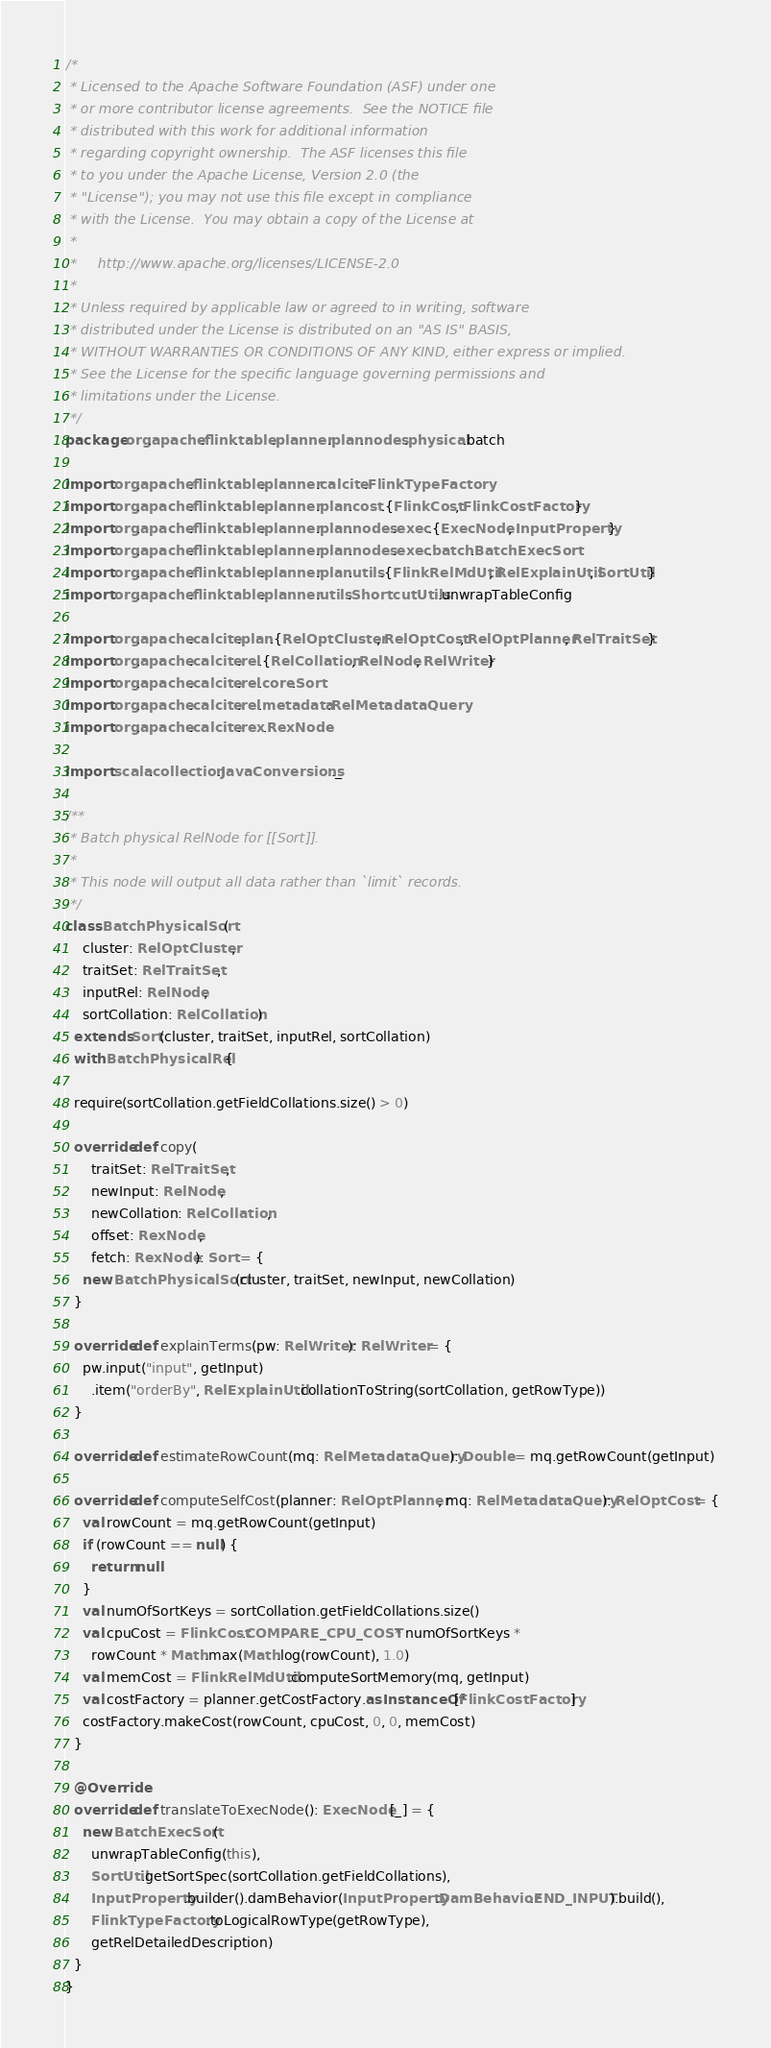<code> <loc_0><loc_0><loc_500><loc_500><_Scala_>/*
 * Licensed to the Apache Software Foundation (ASF) under one
 * or more contributor license agreements.  See the NOTICE file
 * distributed with this work for additional information
 * regarding copyright ownership.  The ASF licenses this file
 * to you under the Apache License, Version 2.0 (the
 * "License"); you may not use this file except in compliance
 * with the License.  You may obtain a copy of the License at
 *
 *     http://www.apache.org/licenses/LICENSE-2.0
 *
 * Unless required by applicable law or agreed to in writing, software
 * distributed under the License is distributed on an "AS IS" BASIS,
 * WITHOUT WARRANTIES OR CONDITIONS OF ANY KIND, either express or implied.
 * See the License for the specific language governing permissions and
 * limitations under the License.
 */
package org.apache.flink.table.planner.plan.nodes.physical.batch

import org.apache.flink.table.planner.calcite.FlinkTypeFactory
import org.apache.flink.table.planner.plan.cost.{FlinkCost, FlinkCostFactory}
import org.apache.flink.table.planner.plan.nodes.exec.{ExecNode, InputProperty}
import org.apache.flink.table.planner.plan.nodes.exec.batch.BatchExecSort
import org.apache.flink.table.planner.plan.utils.{FlinkRelMdUtil, RelExplainUtil, SortUtil}
import org.apache.flink.table.planner.utils.ShortcutUtils.unwrapTableConfig

import org.apache.calcite.plan.{RelOptCluster, RelOptCost, RelOptPlanner, RelTraitSet}
import org.apache.calcite.rel.{RelCollation, RelNode, RelWriter}
import org.apache.calcite.rel.core.Sort
import org.apache.calcite.rel.metadata.RelMetadataQuery
import org.apache.calcite.rex.RexNode

import scala.collection.JavaConversions._

/**
 * Batch physical RelNode for [[Sort]].
 *
 * This node will output all data rather than `limit` records.
 */
class BatchPhysicalSort(
    cluster: RelOptCluster,
    traitSet: RelTraitSet,
    inputRel: RelNode,
    sortCollation: RelCollation)
  extends Sort(cluster, traitSet, inputRel, sortCollation)
  with BatchPhysicalRel {

  require(sortCollation.getFieldCollations.size() > 0)

  override def copy(
      traitSet: RelTraitSet,
      newInput: RelNode,
      newCollation: RelCollation,
      offset: RexNode,
      fetch: RexNode): Sort = {
    new BatchPhysicalSort(cluster, traitSet, newInput, newCollation)
  }

  override def explainTerms(pw: RelWriter): RelWriter = {
    pw.input("input", getInput)
      .item("orderBy", RelExplainUtil.collationToString(sortCollation, getRowType))
  }

  override def estimateRowCount(mq: RelMetadataQuery): Double = mq.getRowCount(getInput)

  override def computeSelfCost(planner: RelOptPlanner, mq: RelMetadataQuery): RelOptCost = {
    val rowCount = mq.getRowCount(getInput)
    if (rowCount == null) {
      return null
    }
    val numOfSortKeys = sortCollation.getFieldCollations.size()
    val cpuCost = FlinkCost.COMPARE_CPU_COST * numOfSortKeys *
      rowCount * Math.max(Math.log(rowCount), 1.0)
    val memCost = FlinkRelMdUtil.computeSortMemory(mq, getInput)
    val costFactory = planner.getCostFactory.asInstanceOf[FlinkCostFactory]
    costFactory.makeCost(rowCount, cpuCost, 0, 0, memCost)
  }

  @Override
  override def translateToExecNode(): ExecNode[_] = {
    new BatchExecSort(
      unwrapTableConfig(this),
      SortUtil.getSortSpec(sortCollation.getFieldCollations),
      InputProperty.builder().damBehavior(InputProperty.DamBehavior.END_INPUT).build(),
      FlinkTypeFactory.toLogicalRowType(getRowType),
      getRelDetailedDescription)
  }
}
</code> 